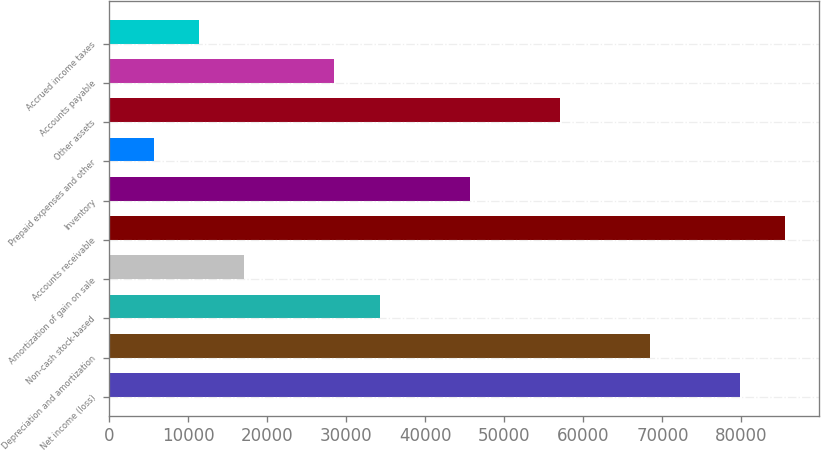<chart> <loc_0><loc_0><loc_500><loc_500><bar_chart><fcel>Net income (loss)<fcel>Depreciation and amortization<fcel>Non-cash stock-based<fcel>Amortization of gain on sale<fcel>Accounts receivable<fcel>Inventory<fcel>Prepaid expenses and other<fcel>Other assets<fcel>Accounts payable<fcel>Accrued income taxes<nl><fcel>79830.4<fcel>68426.2<fcel>34213.6<fcel>17107.3<fcel>85532.5<fcel>45617.8<fcel>5703.1<fcel>57022<fcel>28511.5<fcel>11405.2<nl></chart> 